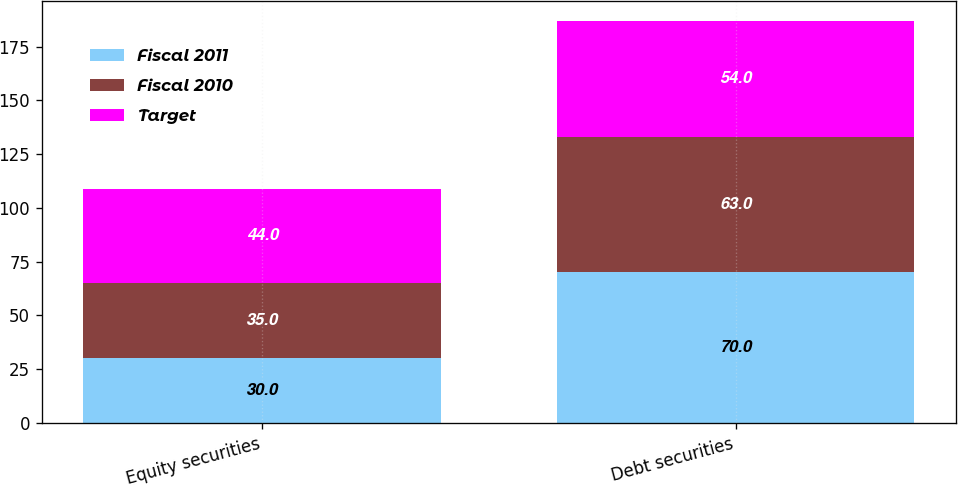Convert chart. <chart><loc_0><loc_0><loc_500><loc_500><stacked_bar_chart><ecel><fcel>Equity securities<fcel>Debt securities<nl><fcel>Fiscal 2011<fcel>30<fcel>70<nl><fcel>Fiscal 2010<fcel>35<fcel>63<nl><fcel>Target<fcel>44<fcel>54<nl></chart> 